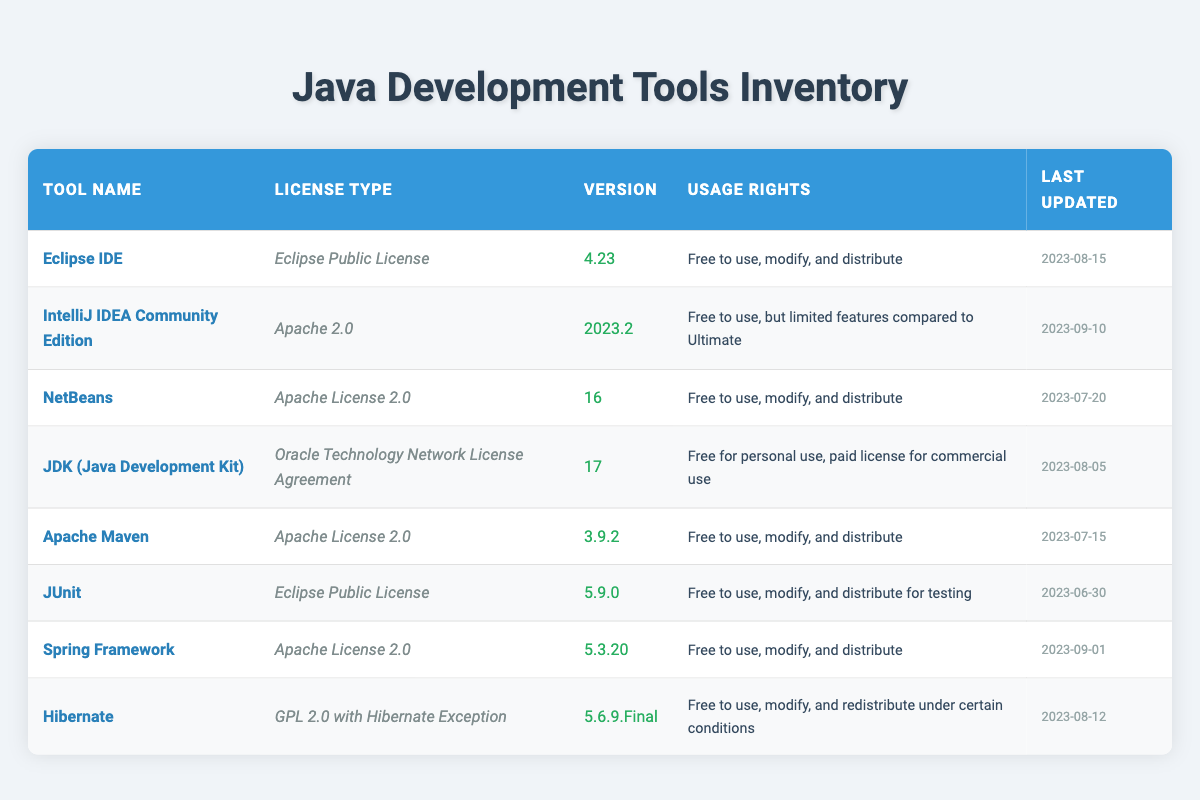What is the license type for Eclipse IDE? The license type for Eclipse IDE is listed as "Eclipse Public License" in the second column of the table under the corresponding tool name.
Answer: Eclipse Public License Which tool has the most recent update? To find the most recent update, we compare the "Last Updated" dates for all the tools. The date "2023-09-10" for IntelliJ IDEA Community Edition is the latest among all the entries.
Answer: IntelliJ IDEA Community Edition How many tools have an Apache License? The table lists three tools with licenses that start with "Apache": IntelliJ IDEA Community Edition, Apache Maven, and Spring Framework. Therefore, the count of tools with an Apache License is 3.
Answer: 3 Is JDK free for commercial use? The usage rights for JDK (Java Development Kit) state that it is "Free for personal use, paid license for commercial use," indicating that it is not free for commercial use.
Answer: No What is the average version number for tools licensed under Apache License 2.0? There are three tools licensed under Apache License 2.0: IntelliJ IDEA Community Edition (2023.2), Apache Maven (3.9.2), and Spring Framework (5.3.20). Converting the version numbers to a common format for averaging: (2023.2 + 3.9.2 + 5.3.20) will be simplified, and I will use 2023 years for this calculation. Therefore, (2023 + 3.9 + 5.3) / 3 = 676.77 approximately. This gives an average of roughly 676.77 for the versions.
Answer: 676.77 Which tool's version is the lowest? By scanning the version numbers listed in the table, JUnit has the lowest version (5.9.0) compared to others. Therefore, it is concluded as the one with the lowest version.
Answer: JUnit How many tools are free to modify and distribute? The following tools have "Free to use, modify, and distribute" listed in their usage rights: Eclipse IDE, NetBeans, Apache Maven, Spring Framework, and Hibernate, totaling five tools that allow such freedoms.
Answer: 5 Which tool has the least restrictive license type? The Eclipse Public License provides users with the freedom to use, modify, and distribute, and is one of the less restrictive licenses among the seven tools.
Answer: Eclipse Public License What is the overall count of tools listed in the inventory? The table lists a total of 8 tools based on the number of entries present in the body of the inventory.
Answer: 8 